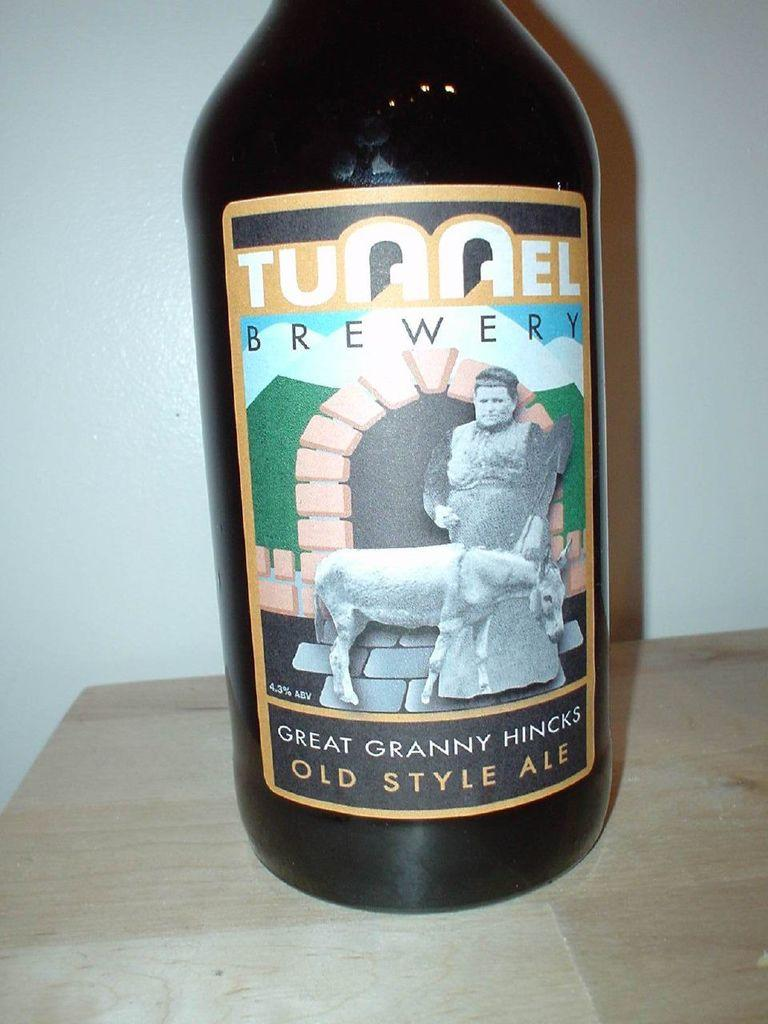<image>
Summarize the visual content of the image. Alcohol with a label that says "Old Style Ale" on it. 